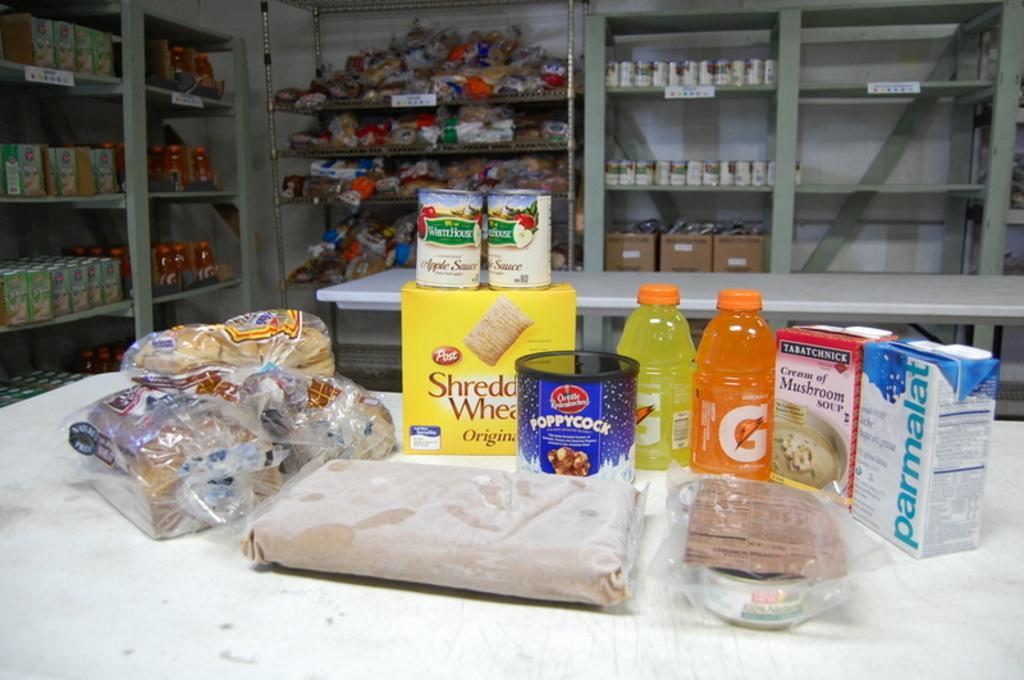<image>
Offer a succinct explanation of the picture presented. A table of groceries including Shredded Wheat and applesauce. 